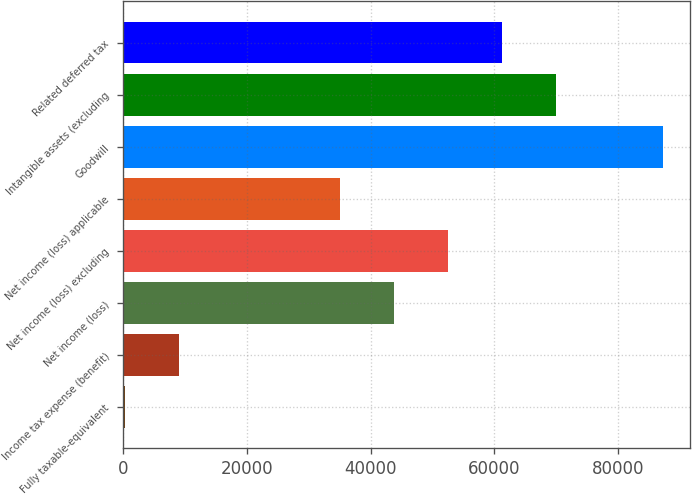<chart> <loc_0><loc_0><loc_500><loc_500><bar_chart><fcel>Fully taxable-equivalent<fcel>Income tax expense (benefit)<fcel>Net income (loss)<fcel>Net income (loss) excluding<fcel>Net income (loss) applicable<fcel>Goodwill<fcel>Intangible assets (excluding<fcel>Related deferred tax<nl><fcel>312<fcel>9012.2<fcel>43813<fcel>52513.2<fcel>35112.8<fcel>87314<fcel>69913.6<fcel>61213.4<nl></chart> 